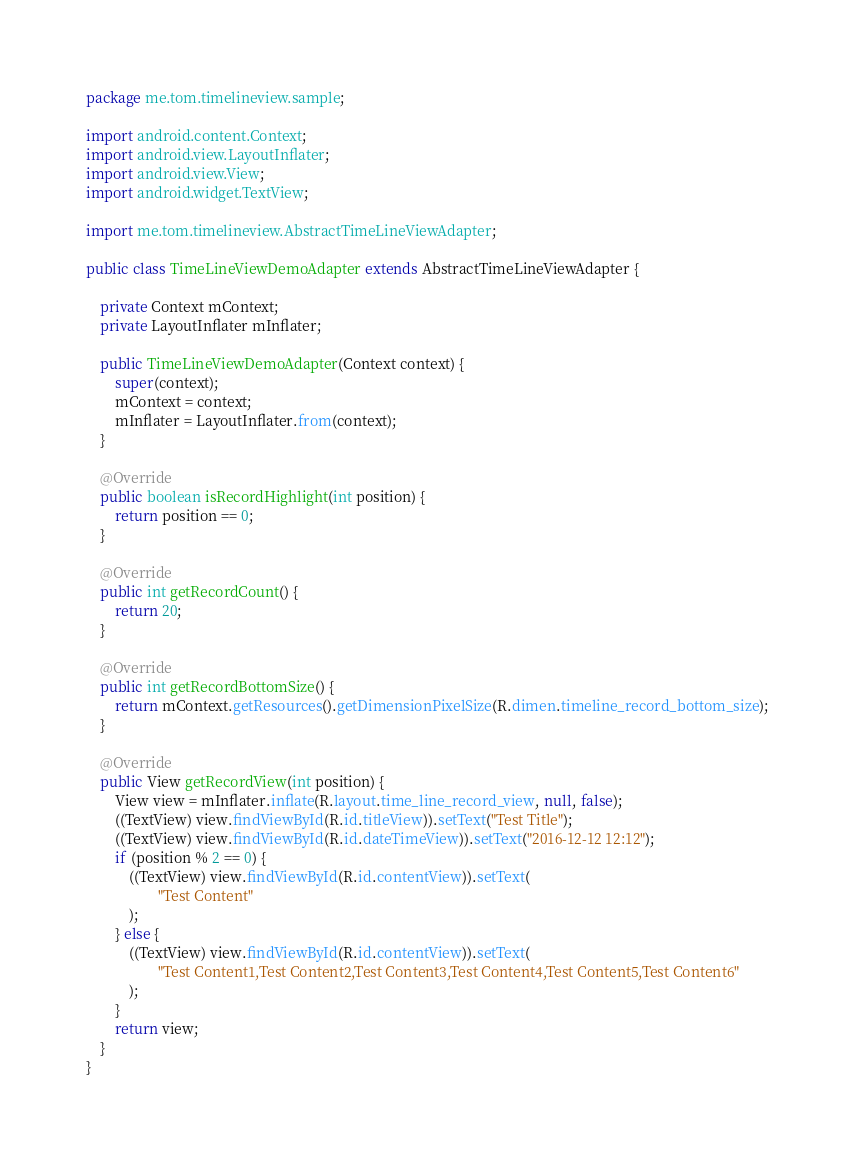<code> <loc_0><loc_0><loc_500><loc_500><_Java_>package me.tom.timelineview.sample;

import android.content.Context;
import android.view.LayoutInflater;
import android.view.View;
import android.widget.TextView;

import me.tom.timelineview.AbstractTimeLineViewAdapter;

public class TimeLineViewDemoAdapter extends AbstractTimeLineViewAdapter {

    private Context mContext;
    private LayoutInflater mInflater;

    public TimeLineViewDemoAdapter(Context context) {
        super(context);
        mContext = context;
        mInflater = LayoutInflater.from(context);
    }

    @Override
    public boolean isRecordHighlight(int position) {
        return position == 0;
    }

    @Override
    public int getRecordCount() {
        return 20;
    }

    @Override
    public int getRecordBottomSize() {
        return mContext.getResources().getDimensionPixelSize(R.dimen.timeline_record_bottom_size);
    }

    @Override
    public View getRecordView(int position) {
        View view = mInflater.inflate(R.layout.time_line_record_view, null, false);
        ((TextView) view.findViewById(R.id.titleView)).setText("Test Title");
        ((TextView) view.findViewById(R.id.dateTimeView)).setText("2016-12-12 12:12");
        if (position % 2 == 0) {
            ((TextView) view.findViewById(R.id.contentView)).setText(
                    "Test Content"
            );
        } else {
            ((TextView) view.findViewById(R.id.contentView)).setText(
                    "Test Content1,Test Content2,Test Content3,Test Content4,Test Content5,Test Content6"
            );
        }
        return view;
    }
}
</code> 